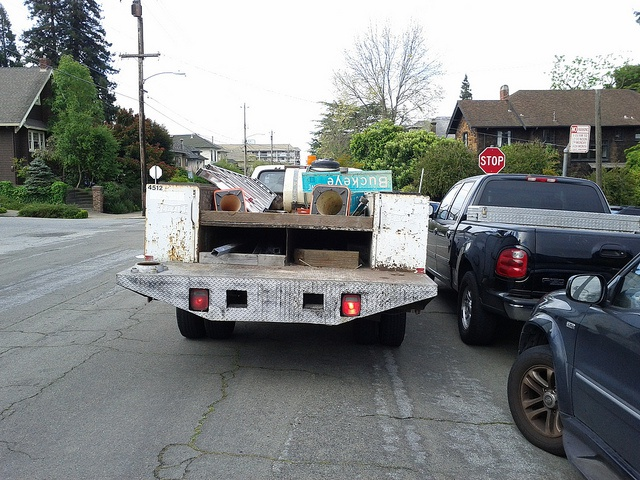Describe the objects in this image and their specific colors. I can see truck in white, lightgray, darkgray, black, and gray tones, truck in white, black, gray, darkgray, and darkblue tones, car in white, black, gray, and darkblue tones, stop sign in white, brown, lightgray, and lightpink tones, and stop sign in white, darkgray, and gray tones in this image. 